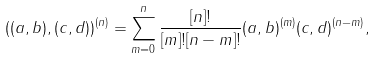Convert formula to latex. <formula><loc_0><loc_0><loc_500><loc_500>\left ( ( a , b ) , ( c , d ) \right ) ^ { ( n ) } = \sum _ { m = 0 } ^ { n } \frac { [ n ] ! } { [ m ] ! [ n - m ] ! } ( a , b ) ^ { ( m ) } ( c , d ) ^ { ( n - m ) } ,</formula> 